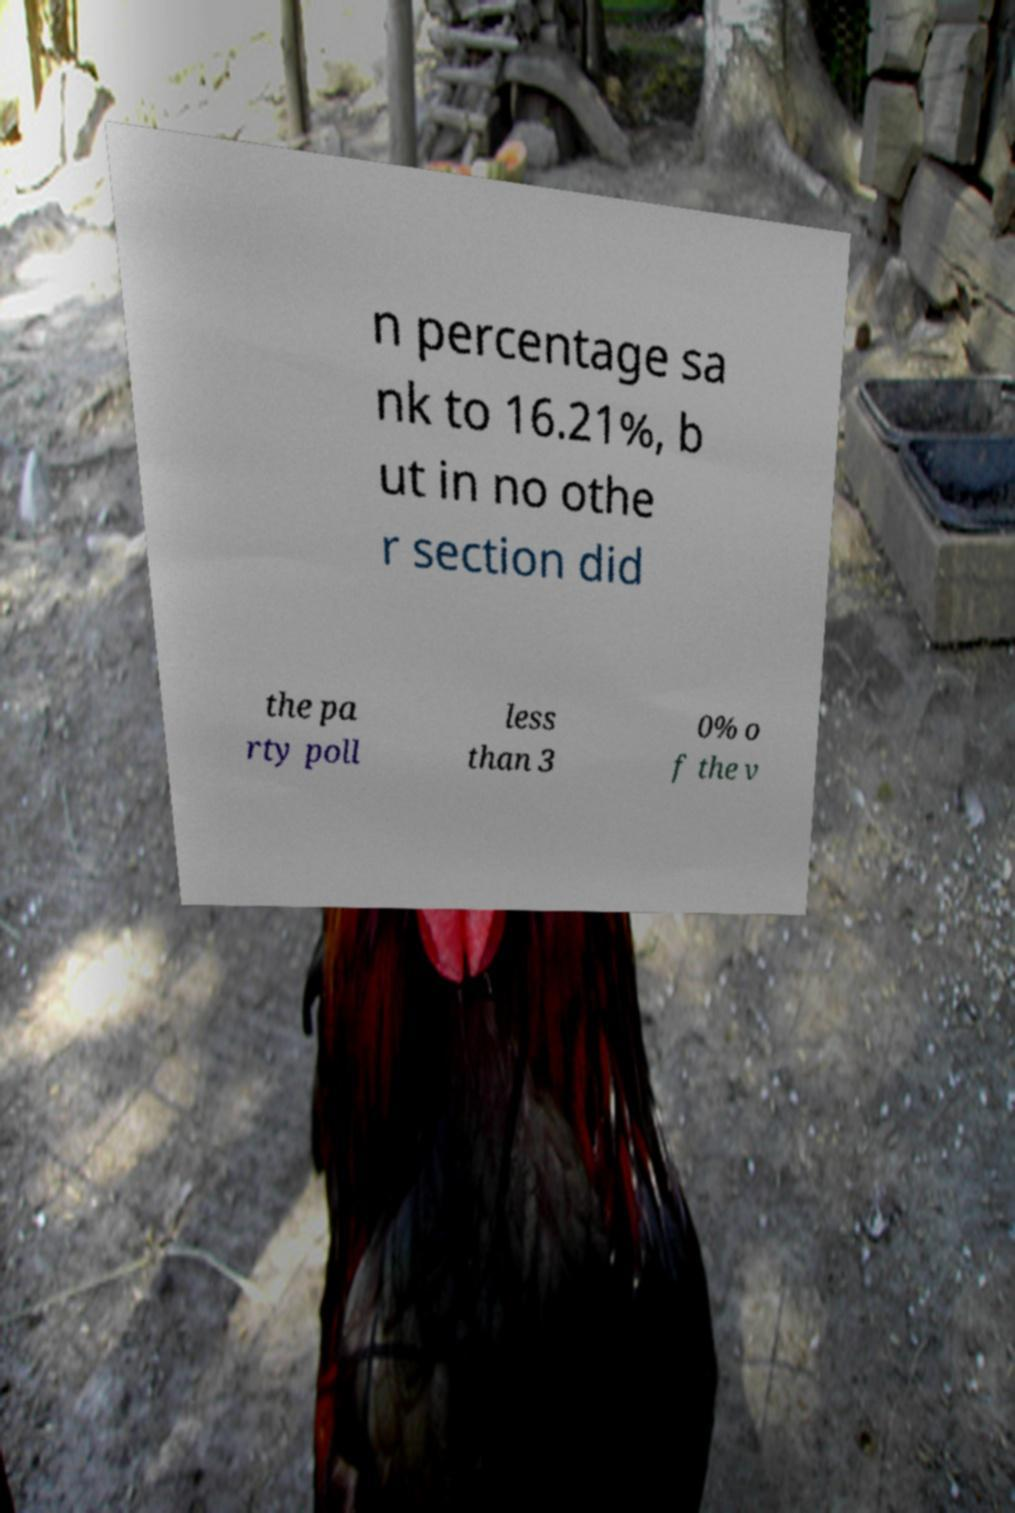Please read and relay the text visible in this image. What does it say? n percentage sa nk to 16.21%, b ut in no othe r section did the pa rty poll less than 3 0% o f the v 